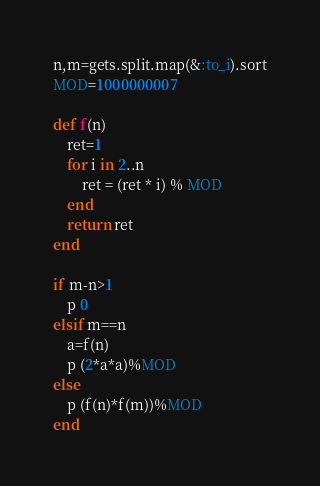Convert code to text. <code><loc_0><loc_0><loc_500><loc_500><_Ruby_>n,m=gets.split.map(&:to_i).sort
MOD=1000000007

def f(n)
    ret=1
    for i in 2..n
        ret = (ret * i) % MOD
    end
    return ret
end

if m-n>1
    p 0
elsif m==n
    a=f(n)
    p (2*a*a)%MOD
else
    p (f(n)*f(m))%MOD
end</code> 